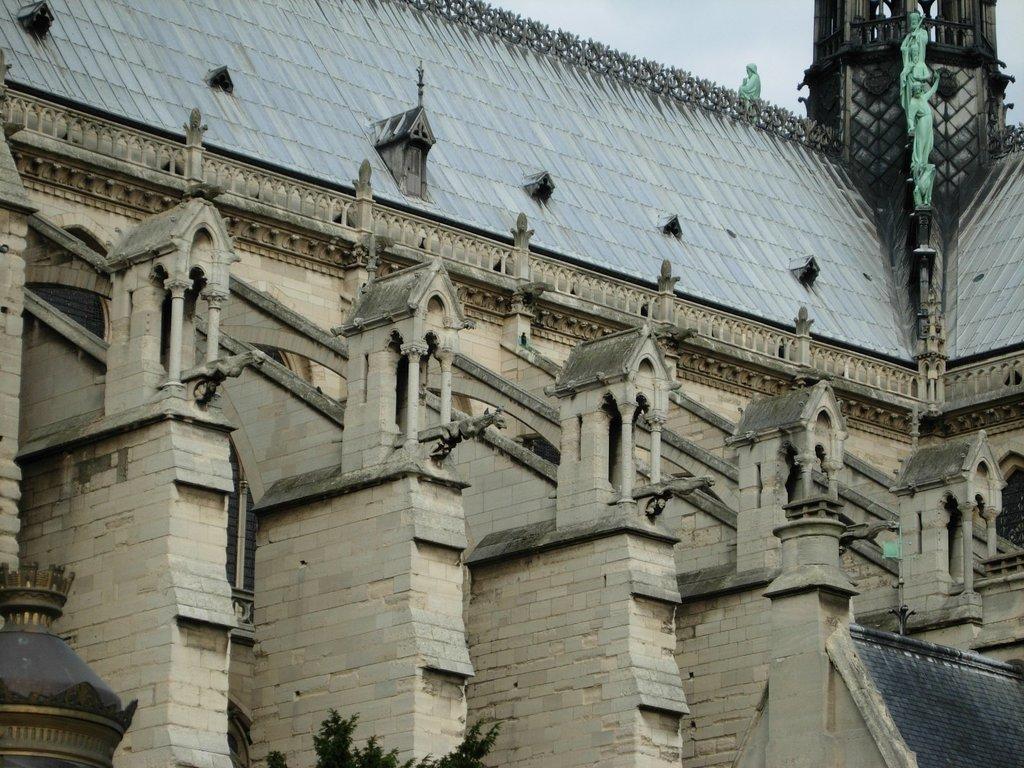Describe this image in one or two sentences. In this image I can see the building which is in ash and grey color. To the right I can see some green color statues to the building. In the back there is a blue sky. 